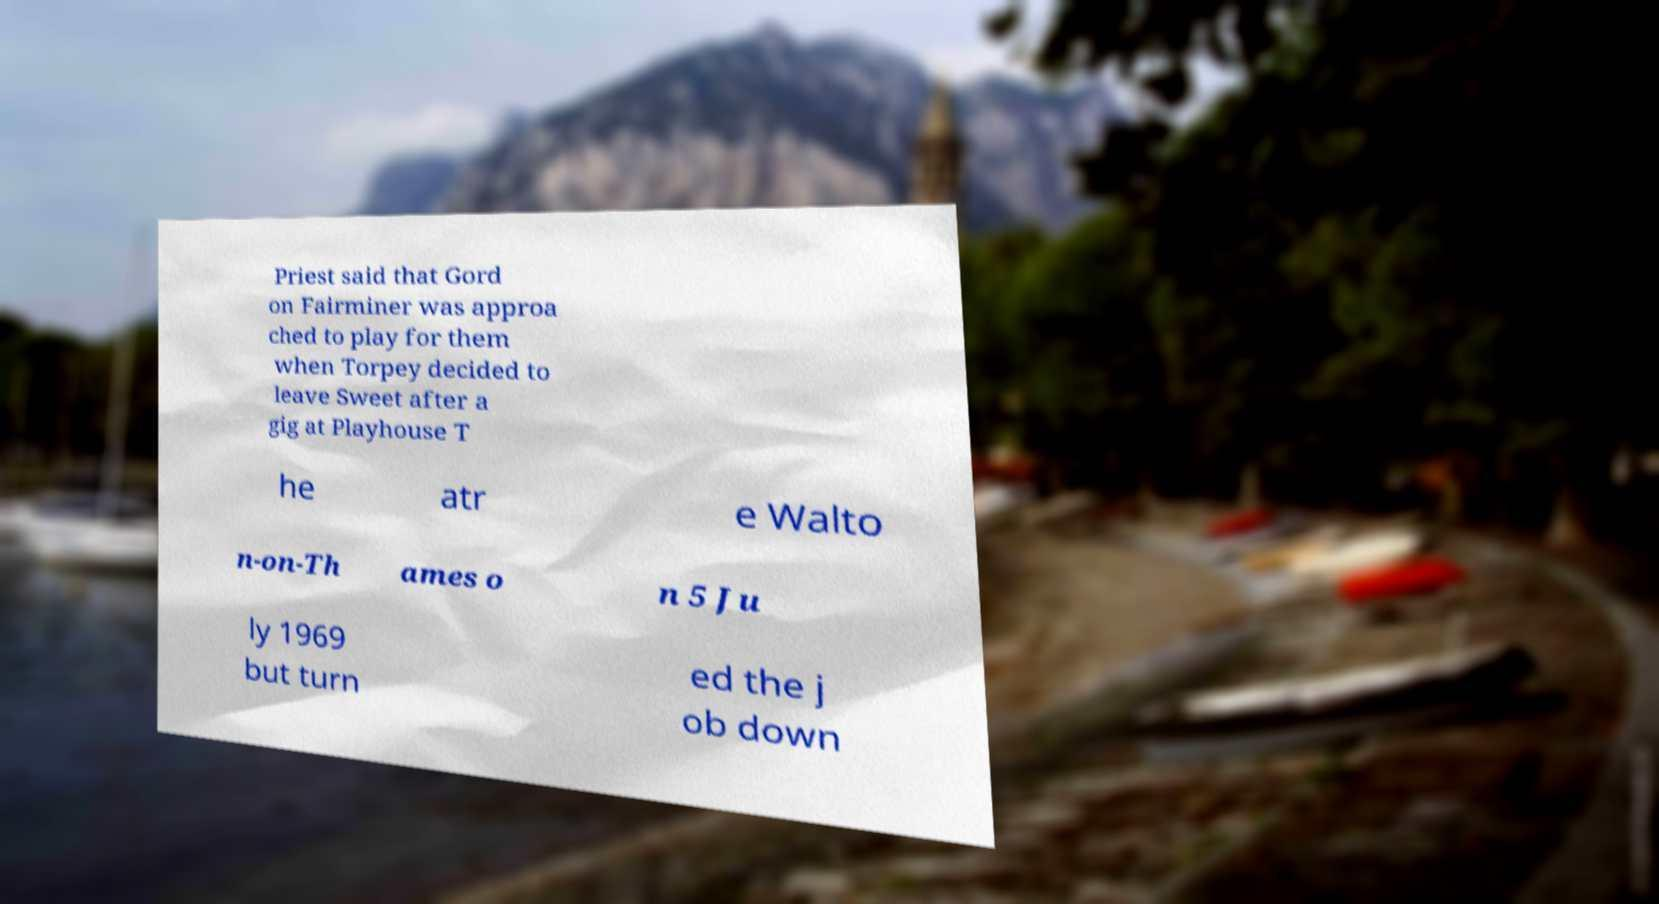Can you read and provide the text displayed in the image?This photo seems to have some interesting text. Can you extract and type it out for me? Priest said that Gord on Fairminer was approa ched to play for them when Torpey decided to leave Sweet after a gig at Playhouse T he atr e Walto n-on-Th ames o n 5 Ju ly 1969 but turn ed the j ob down 